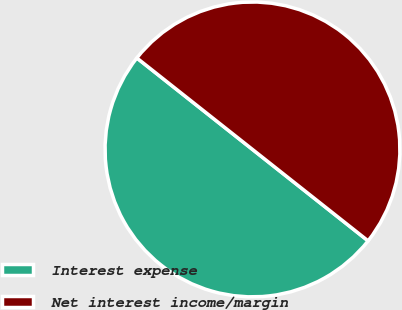Convert chart. <chart><loc_0><loc_0><loc_500><loc_500><pie_chart><fcel>Interest expense<fcel>Net interest income/margin<nl><fcel>50.0%<fcel>50.0%<nl></chart> 